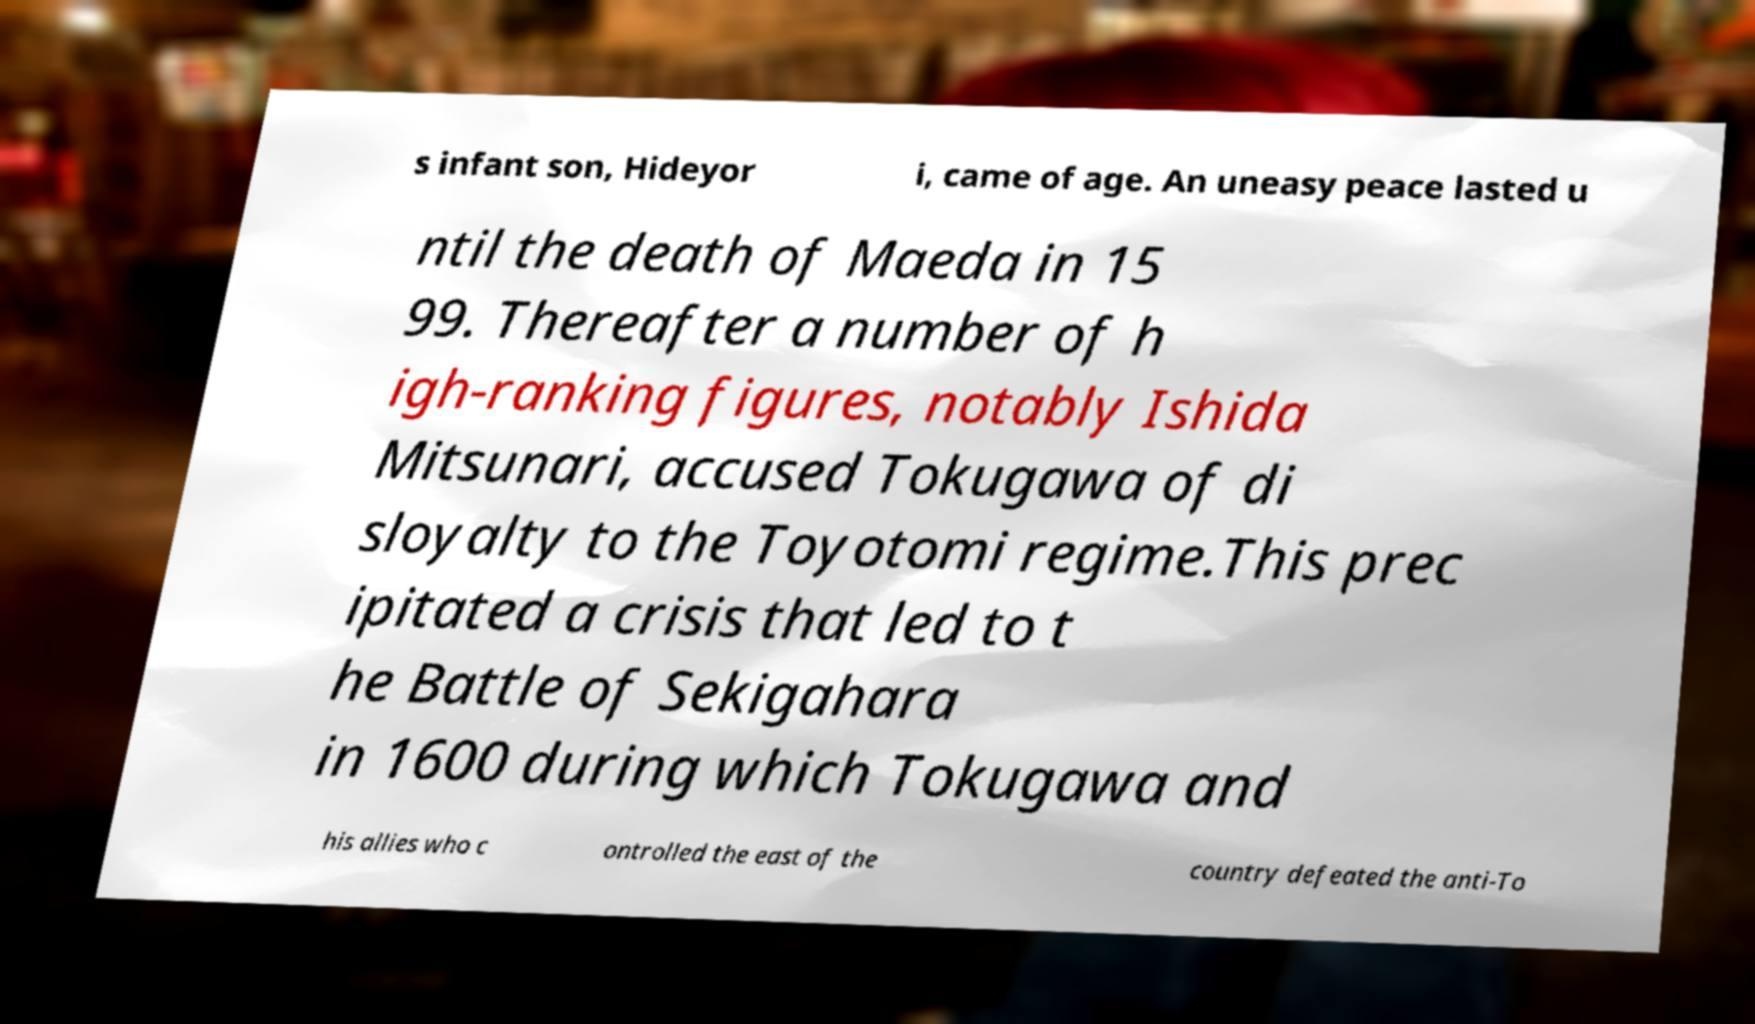Could you assist in decoding the text presented in this image and type it out clearly? s infant son, Hideyor i, came of age. An uneasy peace lasted u ntil the death of Maeda in 15 99. Thereafter a number of h igh-ranking figures, notably Ishida Mitsunari, accused Tokugawa of di sloyalty to the Toyotomi regime.This prec ipitated a crisis that led to t he Battle of Sekigahara in 1600 during which Tokugawa and his allies who c ontrolled the east of the country defeated the anti-To 